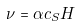Convert formula to latex. <formula><loc_0><loc_0><loc_500><loc_500>\nu = \alpha c _ { S } H</formula> 